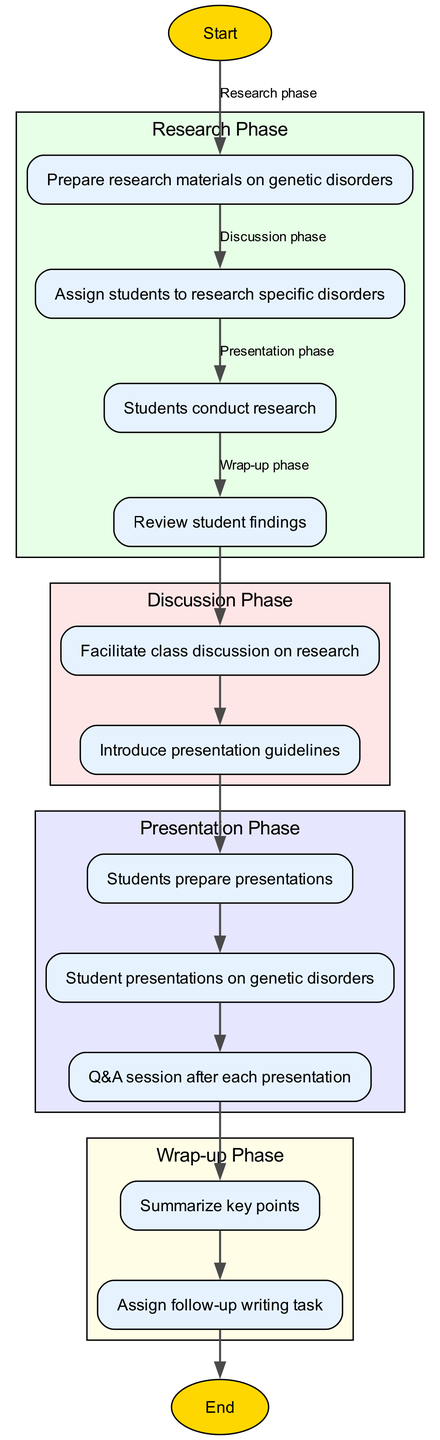What is the starting point of the diagram? The diagram begins with the node labeled "Start". This is the first node in the sequence, indicating where the lesson plan execution initiates.
Answer: Start How many nodes are present in the diagram? There are a total of 13 nodes in the diagram. Each node represents a distinct step in the lesson plan execution process.
Answer: 13 What is the last step in the process? The lesson plan execution concludes with the node labeled "End". This indicates the completion of the activity sequence.
Answer: End Which phase includes the "Facilitate class discussion on research" step? This step is part of the "Discussion Phase". It falls under the nodes associated with engaging students in dialogue about their findings.
Answer: Discussion Phase How many edges connect the nodes in the diagram? There are 12 edges in the diagram. Each edge represents a transition or flow from one step to the next in the lesson plan execution.
Answer: 12 What activity follows "Students prepare presentations"? The next activity is "Student presentations on genetic disorders". This indicates the sequence of events following the preparation step.
Answer: Student presentations on genetic disorders In which phase does the "Q&A session after each presentation" occur? The "Q&A session after each presentation" takes place during the "Presentation Phase". This is where students present their research findings.
Answer: Presentation Phase Which step comes directly after "Review student findings"? The step that follows "Review student findings" is "Facilitate class discussion on research". This shows the flow from evaluating research to engaging in discussion.
Answer: Facilitate class discussion on research What are the total phases outlined in the diagram? The diagram outlines four distinct phases: Research Phase, Discussion Phase, Presentation Phase, and Wrap-up Phase. These phases categorize the steps in the lesson plan execution.
Answer: Four phases 